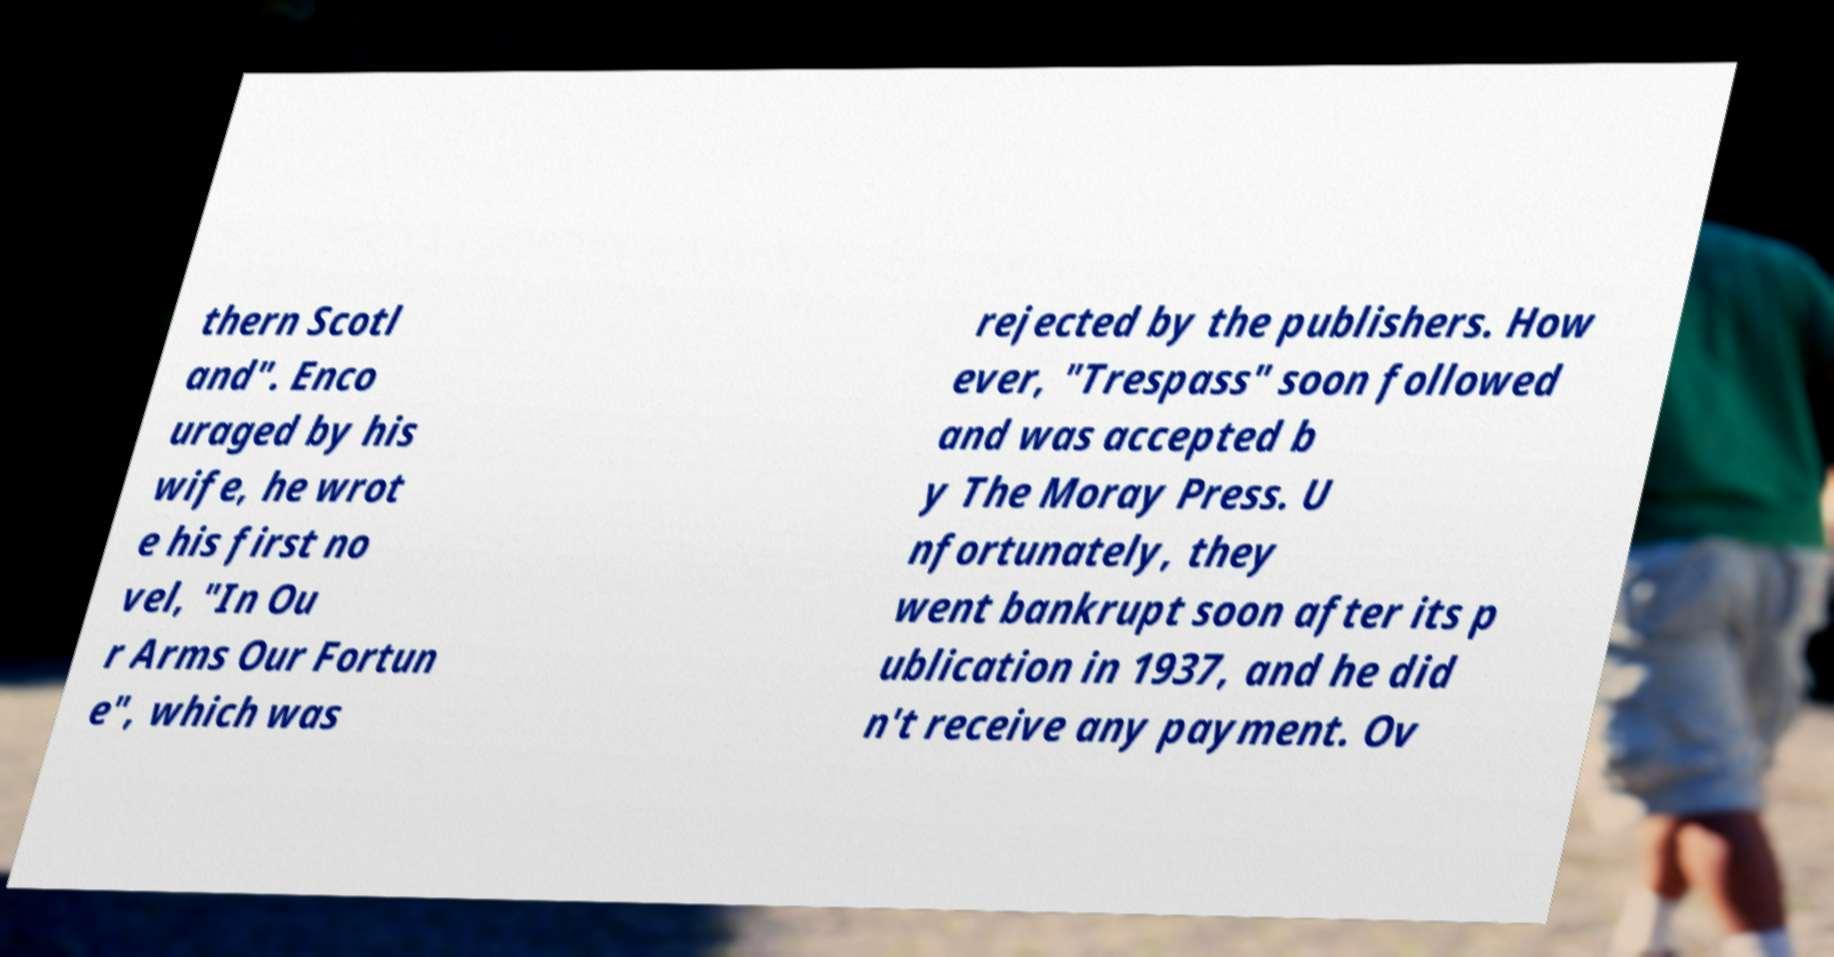Please read and relay the text visible in this image. What does it say? thern Scotl and". Enco uraged by his wife, he wrot e his first no vel, "In Ou r Arms Our Fortun e", which was rejected by the publishers. How ever, "Trespass" soon followed and was accepted b y The Moray Press. U nfortunately, they went bankrupt soon after its p ublication in 1937, and he did n't receive any payment. Ov 